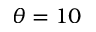Convert formula to latex. <formula><loc_0><loc_0><loc_500><loc_500>\theta = 1 0</formula> 